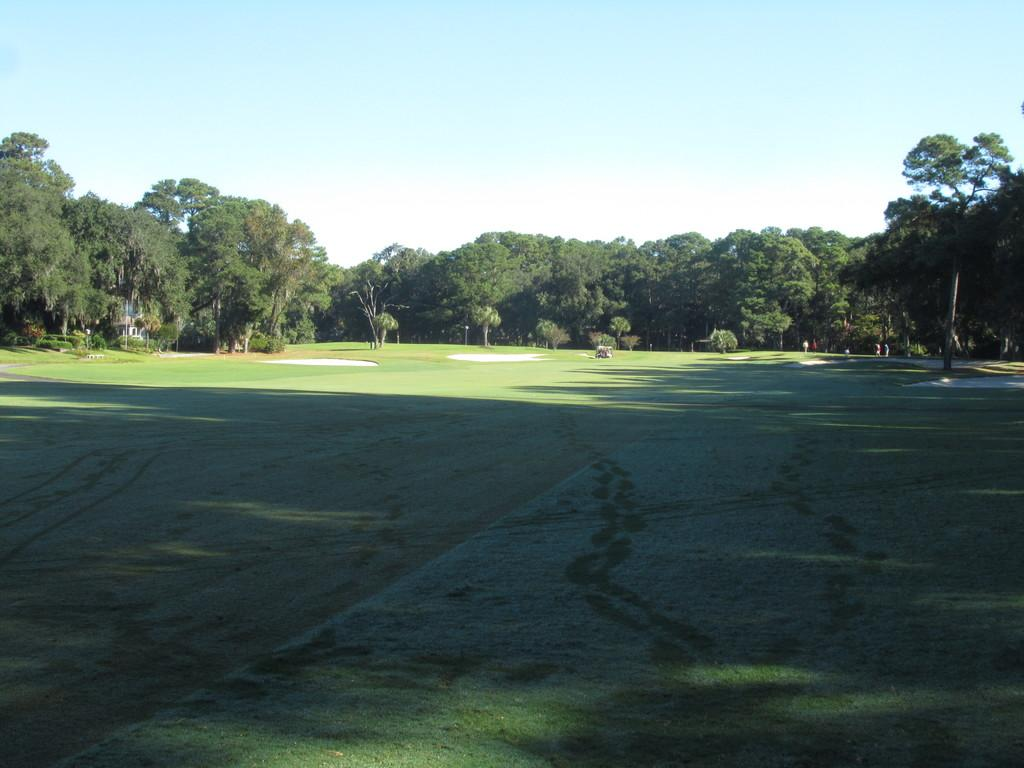What type of vegetation can be seen in the background of the image? There are trees in the background of the image. What type of ground cover is at the bottom of the image? There is grass at the bottom of the image. What part of the natural environment is visible at the top of the image? The sky is visible at the top of the image. What type of celery is growing in the neck of the person in the image? There is no person or celery present in the image. What type of building can be seen in the background of the image? There is no building visible in the image; only trees, grass, and sky are present. 